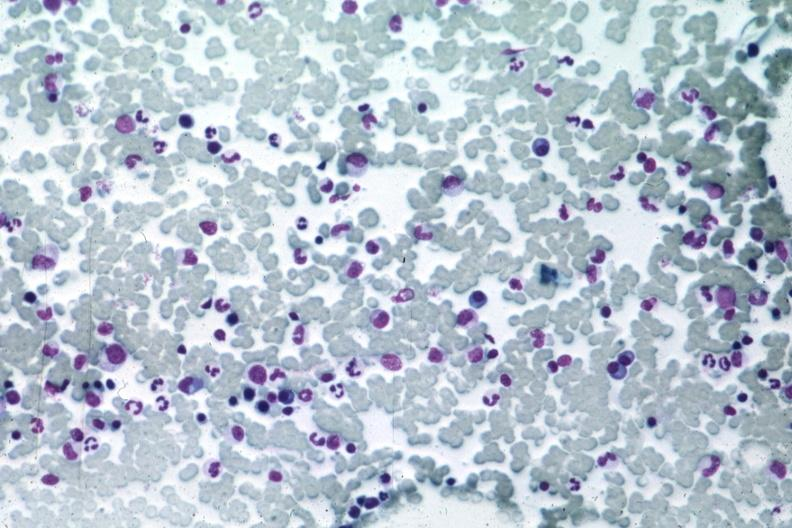what is present?
Answer the question using a single word or phrase. Hematologic 